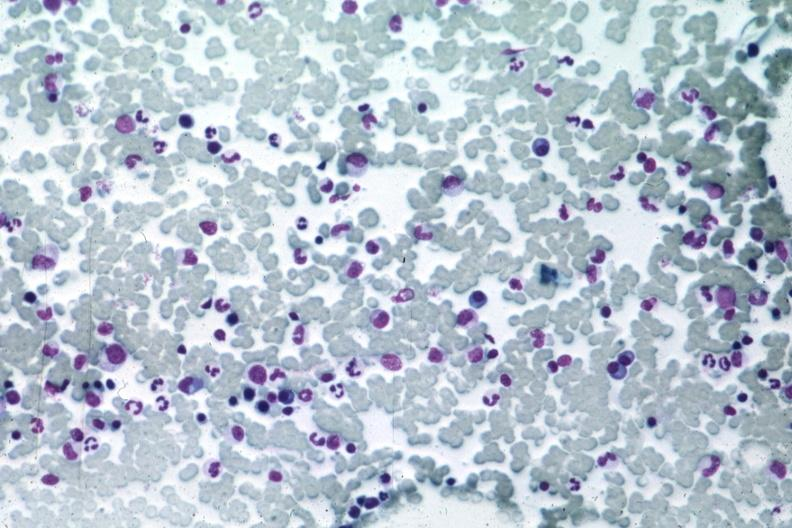what is present?
Answer the question using a single word or phrase. Hematologic 